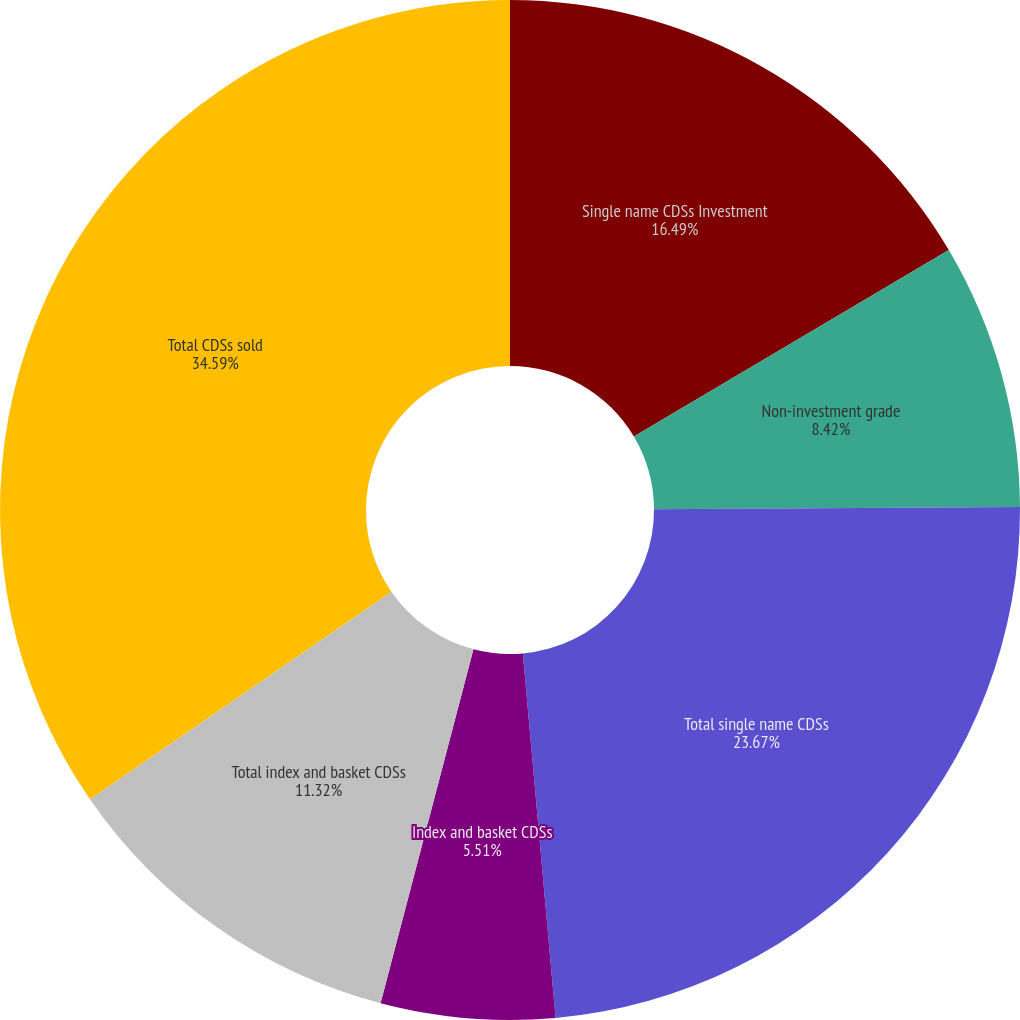Convert chart. <chart><loc_0><loc_0><loc_500><loc_500><pie_chart><fcel>Single name CDSs Investment<fcel>Non-investment grade<fcel>Total single name CDSs<fcel>Index and basket CDSs<fcel>Total index and basket CDSs<fcel>Total CDSs sold<nl><fcel>16.49%<fcel>8.42%<fcel>23.67%<fcel>5.51%<fcel>11.32%<fcel>34.6%<nl></chart> 